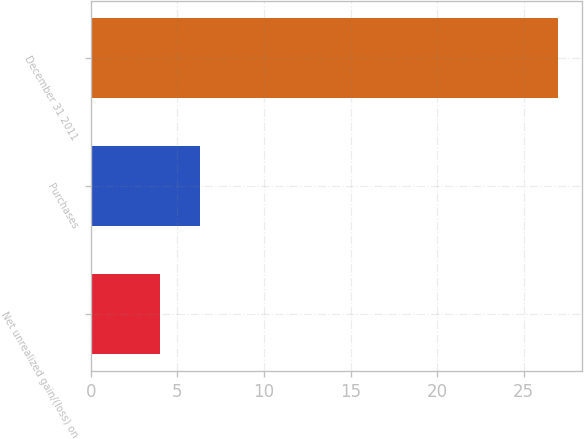<chart> <loc_0><loc_0><loc_500><loc_500><bar_chart><fcel>Net unrealized gain/(loss) on<fcel>Purchases<fcel>December 31 2011<nl><fcel>4<fcel>6.3<fcel>27<nl></chart> 